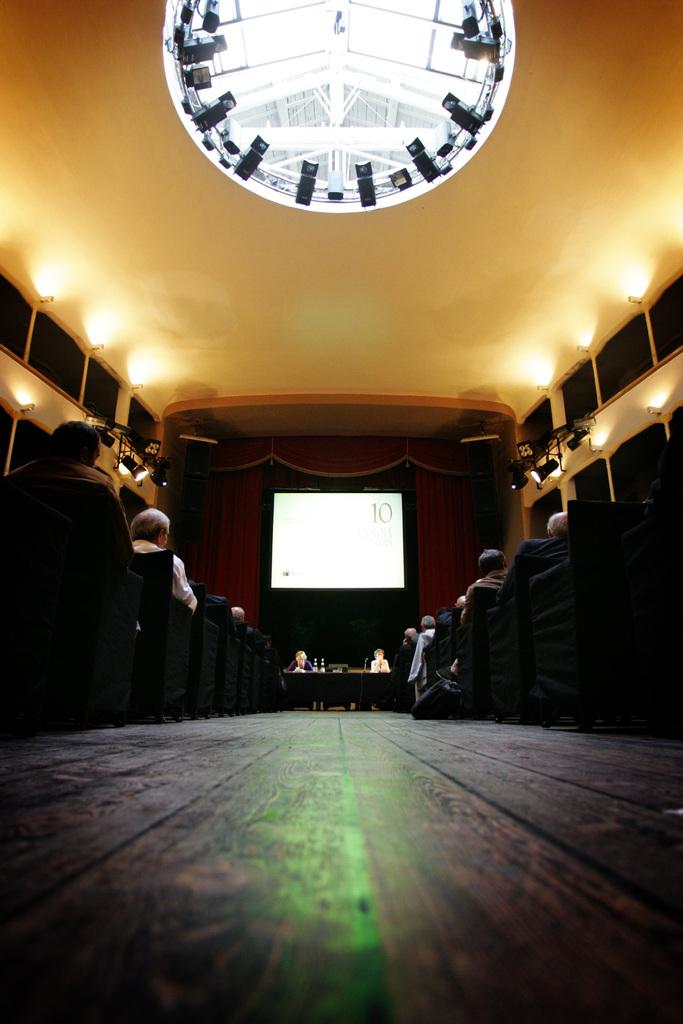How many people are in the image? There is a group of people in the image. What are the people doing in the image? The people are seated on chairs. What can be seen in the background of the image? There is a projector screen, lights, and curtains visible in the background of the image. What type of bean is being used as a chair in the image? There is no bean being used as a chair in the image; the people are seated on regular chairs. 